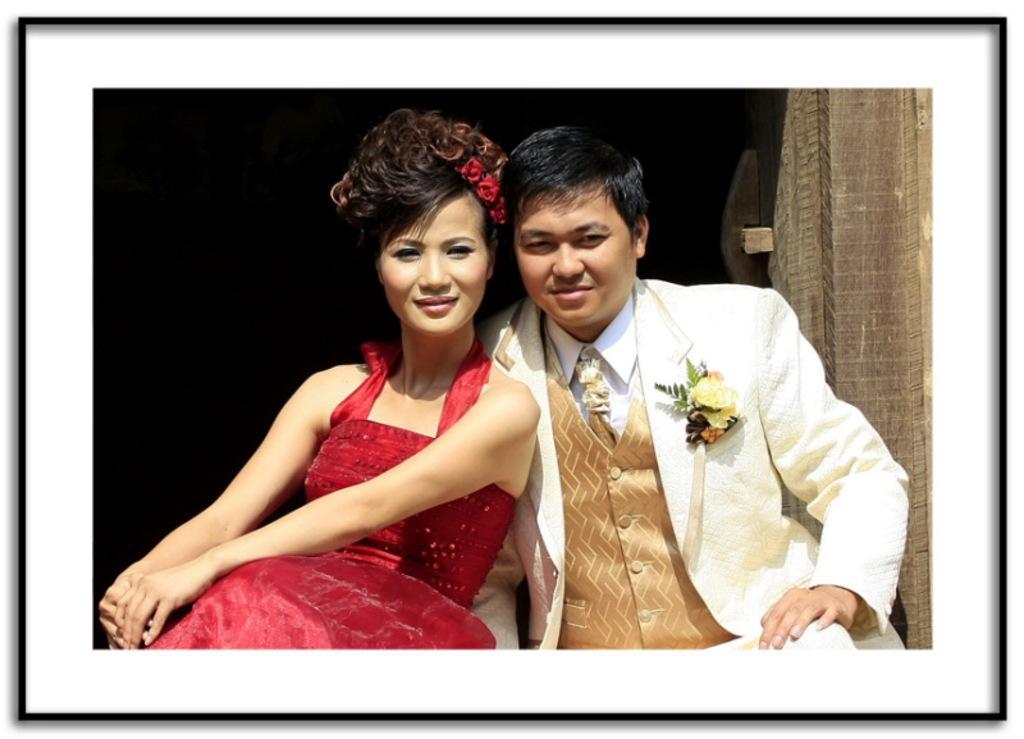Describe this image in one or two sentences. In this image we can see a lady wearing red color dress and a man wearing white color suit. There is a wooden object to the right side of the image. This image has borders. 